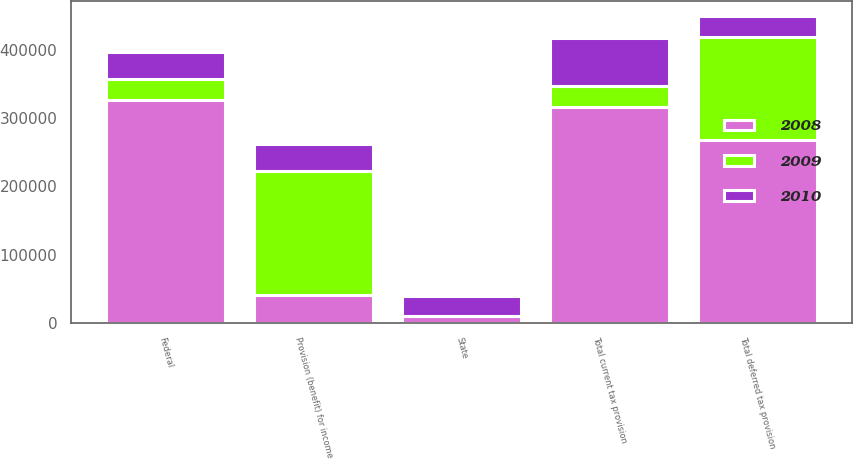<chart> <loc_0><loc_0><loc_500><loc_500><stacked_bar_chart><ecel><fcel>Federal<fcel>State<fcel>Total current tax provision<fcel>Total deferred tax provision<fcel>Provision (benefit) for income<nl><fcel>2010<fcel>40675<fcel>29539<fcel>70214<fcel>30250<fcel>39964<nl><fcel>2008<fcel>326659<fcel>9860<fcel>316799<fcel>267205<fcel>40319.5<nl><fcel>2009<fcel>30164<fcel>102<fcel>30266<fcel>151936<fcel>182202<nl></chart> 